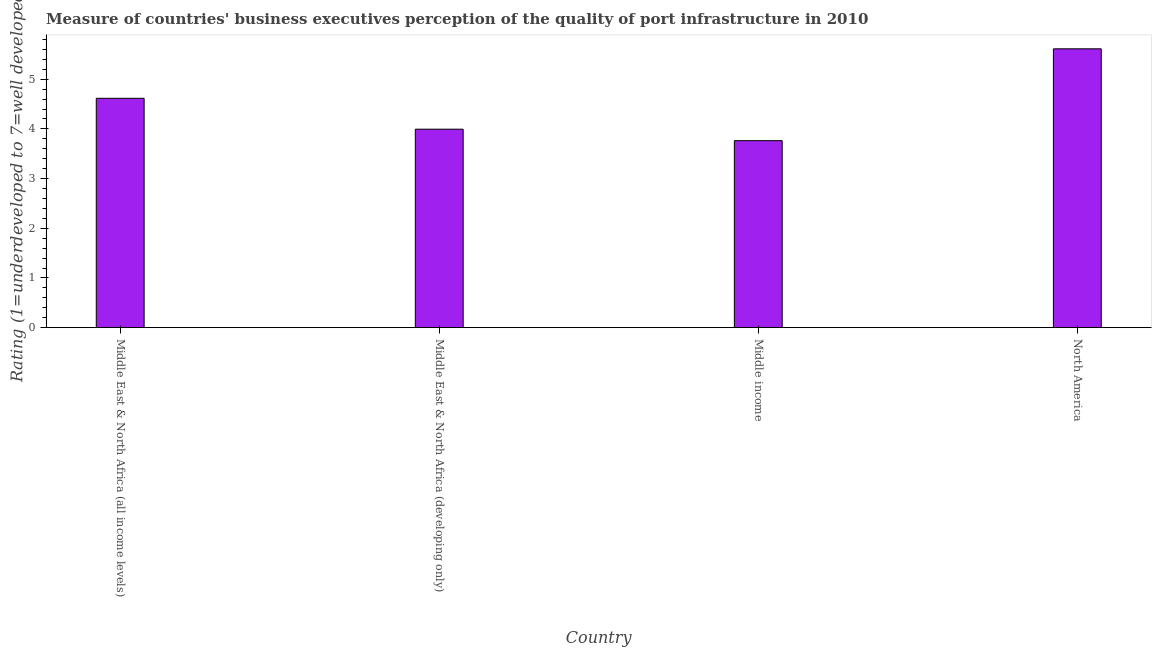What is the title of the graph?
Give a very brief answer. Measure of countries' business executives perception of the quality of port infrastructure in 2010. What is the label or title of the Y-axis?
Provide a short and direct response. Rating (1=underdeveloped to 7=well developed) . What is the rating measuring quality of port infrastructure in North America?
Your response must be concise. 5.61. Across all countries, what is the maximum rating measuring quality of port infrastructure?
Provide a short and direct response. 5.61. Across all countries, what is the minimum rating measuring quality of port infrastructure?
Ensure brevity in your answer.  3.76. In which country was the rating measuring quality of port infrastructure maximum?
Your response must be concise. North America. What is the sum of the rating measuring quality of port infrastructure?
Your answer should be compact. 17.98. What is the difference between the rating measuring quality of port infrastructure in Middle income and North America?
Keep it short and to the point. -1.85. What is the average rating measuring quality of port infrastructure per country?
Provide a short and direct response. 4.5. What is the median rating measuring quality of port infrastructure?
Offer a very short reply. 4.3. What is the ratio of the rating measuring quality of port infrastructure in Middle East & North Africa (all income levels) to that in Middle East & North Africa (developing only)?
Provide a short and direct response. 1.16. Is the sum of the rating measuring quality of port infrastructure in Middle East & North Africa (developing only) and Middle income greater than the maximum rating measuring quality of port infrastructure across all countries?
Keep it short and to the point. Yes. What is the difference between the highest and the lowest rating measuring quality of port infrastructure?
Your answer should be very brief. 1.85. In how many countries, is the rating measuring quality of port infrastructure greater than the average rating measuring quality of port infrastructure taken over all countries?
Make the answer very short. 2. Are all the bars in the graph horizontal?
Keep it short and to the point. No. What is the difference between two consecutive major ticks on the Y-axis?
Keep it short and to the point. 1. Are the values on the major ticks of Y-axis written in scientific E-notation?
Your answer should be compact. No. What is the Rating (1=underdeveloped to 7=well developed)  of Middle East & North Africa (all income levels)?
Your response must be concise. 4.62. What is the Rating (1=underdeveloped to 7=well developed)  in Middle East & North Africa (developing only)?
Ensure brevity in your answer.  3.99. What is the Rating (1=underdeveloped to 7=well developed)  in Middle income?
Offer a very short reply. 3.76. What is the Rating (1=underdeveloped to 7=well developed)  in North America?
Your answer should be compact. 5.61. What is the difference between the Rating (1=underdeveloped to 7=well developed)  in Middle East & North Africa (all income levels) and Middle East & North Africa (developing only)?
Offer a very short reply. 0.62. What is the difference between the Rating (1=underdeveloped to 7=well developed)  in Middle East & North Africa (all income levels) and Middle income?
Provide a succinct answer. 0.85. What is the difference between the Rating (1=underdeveloped to 7=well developed)  in Middle East & North Africa (all income levels) and North America?
Provide a short and direct response. -1. What is the difference between the Rating (1=underdeveloped to 7=well developed)  in Middle East & North Africa (developing only) and Middle income?
Offer a terse response. 0.23. What is the difference between the Rating (1=underdeveloped to 7=well developed)  in Middle East & North Africa (developing only) and North America?
Ensure brevity in your answer.  -1.62. What is the difference between the Rating (1=underdeveloped to 7=well developed)  in Middle income and North America?
Ensure brevity in your answer.  -1.85. What is the ratio of the Rating (1=underdeveloped to 7=well developed)  in Middle East & North Africa (all income levels) to that in Middle East & North Africa (developing only)?
Your answer should be compact. 1.16. What is the ratio of the Rating (1=underdeveloped to 7=well developed)  in Middle East & North Africa (all income levels) to that in Middle income?
Offer a very short reply. 1.23. What is the ratio of the Rating (1=underdeveloped to 7=well developed)  in Middle East & North Africa (all income levels) to that in North America?
Keep it short and to the point. 0.82. What is the ratio of the Rating (1=underdeveloped to 7=well developed)  in Middle East & North Africa (developing only) to that in Middle income?
Ensure brevity in your answer.  1.06. What is the ratio of the Rating (1=underdeveloped to 7=well developed)  in Middle East & North Africa (developing only) to that in North America?
Your answer should be compact. 0.71. What is the ratio of the Rating (1=underdeveloped to 7=well developed)  in Middle income to that in North America?
Keep it short and to the point. 0.67. 